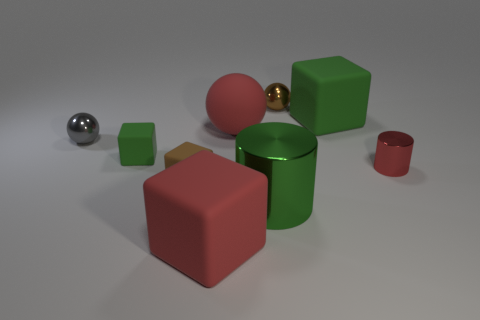How many other objects are the same size as the brown rubber block?
Offer a very short reply. 4. The other red thing that is the same shape as the large metal object is what size?
Offer a terse response. Small. The tiny brown thing to the left of the red rubber sphere has what shape?
Give a very brief answer. Cube. There is a small metal object to the right of the brown ball behind the brown block; what color is it?
Keep it short and to the point. Red. What number of objects are either big green objects in front of the red metallic cylinder or big metallic blocks?
Your response must be concise. 1. Do the brown matte cube and the rubber thing right of the brown metallic ball have the same size?
Offer a terse response. No. What number of tiny objects are purple rubber spheres or gray objects?
Make the answer very short. 1. The tiny gray thing is what shape?
Your response must be concise. Sphere. What is the size of the rubber sphere that is the same color as the small cylinder?
Give a very brief answer. Large. Is there a cyan cylinder made of the same material as the tiny green object?
Your answer should be very brief. No. 